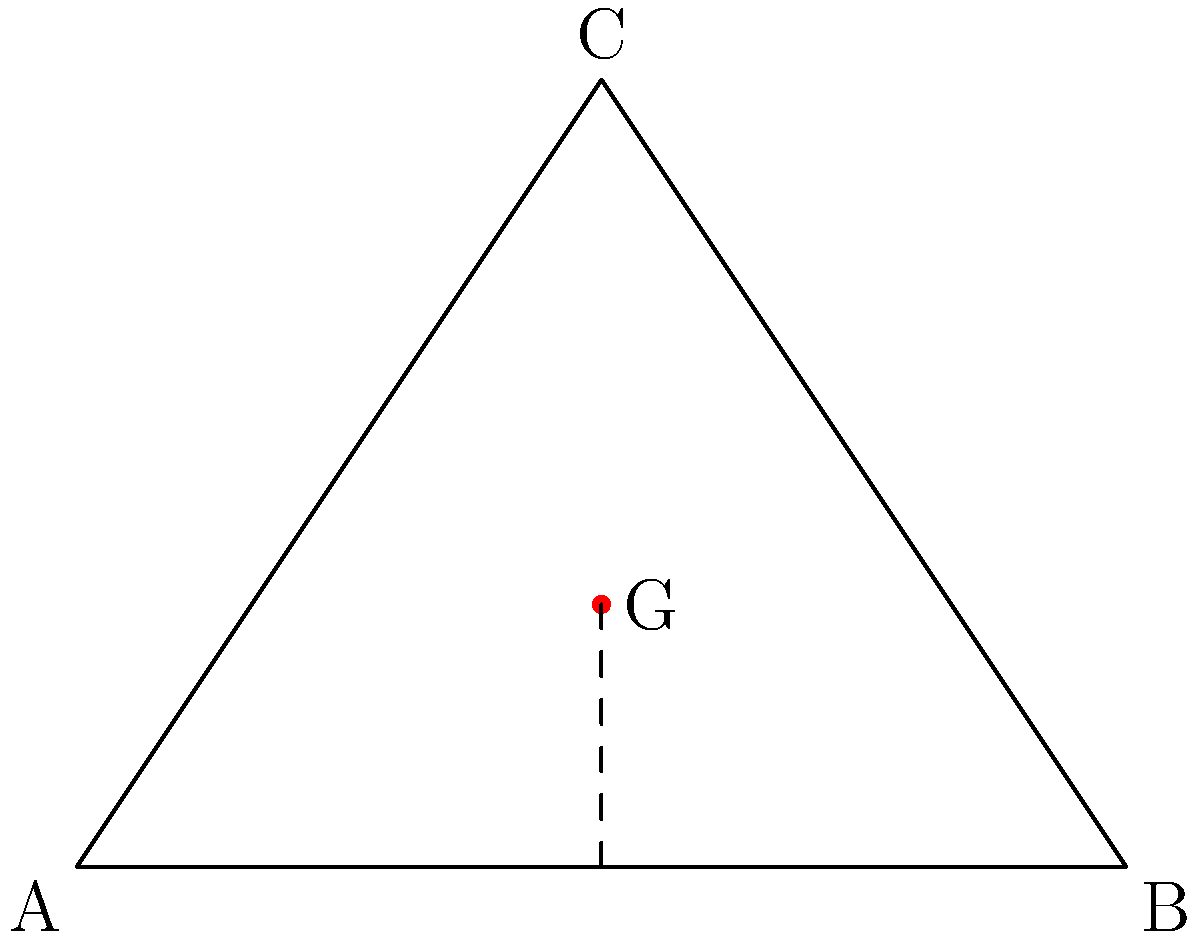Uma escultura triangular tem seu centro de gravidade localizado a 1/3 da altura do triângulo. Considerando a estabilidade da obra, como essa posição do centro de gravidade afeta a percepção e a experiência do espectador em relação à instalação? Para entender o impacto do centro de gravidade na percepção da escultura, vamos analisar passo a passo:

1. Posição do centro de gravidade:
   - O centro de gravidade (G) está localizado a 1/3 da altura do triângulo.
   - Isso significa que G está mais próximo da base do que do topo.

2. Estabilidade física:
   - Um centro de gravidade mais baixo aumenta a estabilidade da escultura.
   - A obra terá menos tendência a tombar, mesmo com pequenas perturbações.

3. Percepção visual:
   - O espectador inconscientemente percebe essa estabilidade.
   - Isso pode criar uma sensação de solidez e permanência na obra.

4. Contraste com a forma:
   - O triângulo, por sua natureza, sugere uma forma ascendente e dinâmica.
   - O centro de gravidade baixo cria um contraste interessante com essa forma.

5. Tensão artística:
   - Esse contraste entre a forma ascendente e o peso visual mais baixo pode criar uma tensão artística.
   - Isso pode ser interpretado como um equilíbrio entre aspiração e realidade.

6. Experiência do espectador:
   - O espectador pode sentir uma mistura de estabilidade e dinamismo.
   - Isso pode levar a uma experiência mais complexa e envolvente da obra.

7. Impacto no mercado:
   - Uma obra que combina estabilidade física com tensão artística pode ser vista como mais sofisticada.
   - Isso pode aumentar seu valor e apelo no mercado de arte.
Answer: Cria tensão entre estabilidade física e dinamismo visual, enriquecendo a experiência do espectador e potencialmente aumentando o valor da obra. 